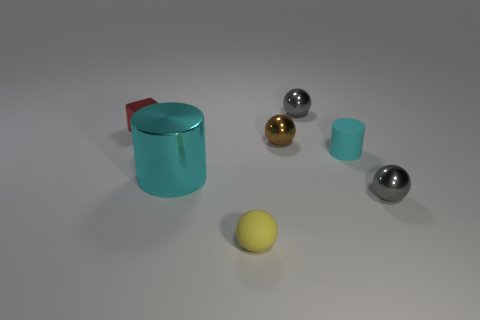Is there anything else that is the same size as the shiny cylinder?
Ensure brevity in your answer.  No. Is the number of red objects behind the red metallic cube less than the number of small cyan matte cylinders?
Provide a short and direct response. Yes. What number of small yellow rubber cubes are there?
Your answer should be very brief. 0. There is a small brown metallic thing; does it have the same shape as the cyan metal object that is in front of the small cyan thing?
Your response must be concise. No. Is the number of tiny shiny spheres on the right side of the brown object less than the number of small objects right of the large metallic thing?
Keep it short and to the point. Yes. Is there any other thing that has the same shape as the cyan rubber object?
Offer a very short reply. Yes. Is the shape of the large cyan shiny object the same as the small cyan object?
Provide a succinct answer. Yes. The red metallic block has what size?
Your answer should be compact. Small. The metallic object that is both behind the large cyan cylinder and left of the small yellow rubber sphere is what color?
Provide a short and direct response. Red. Are there more yellow matte things than gray metal things?
Offer a very short reply. No. 